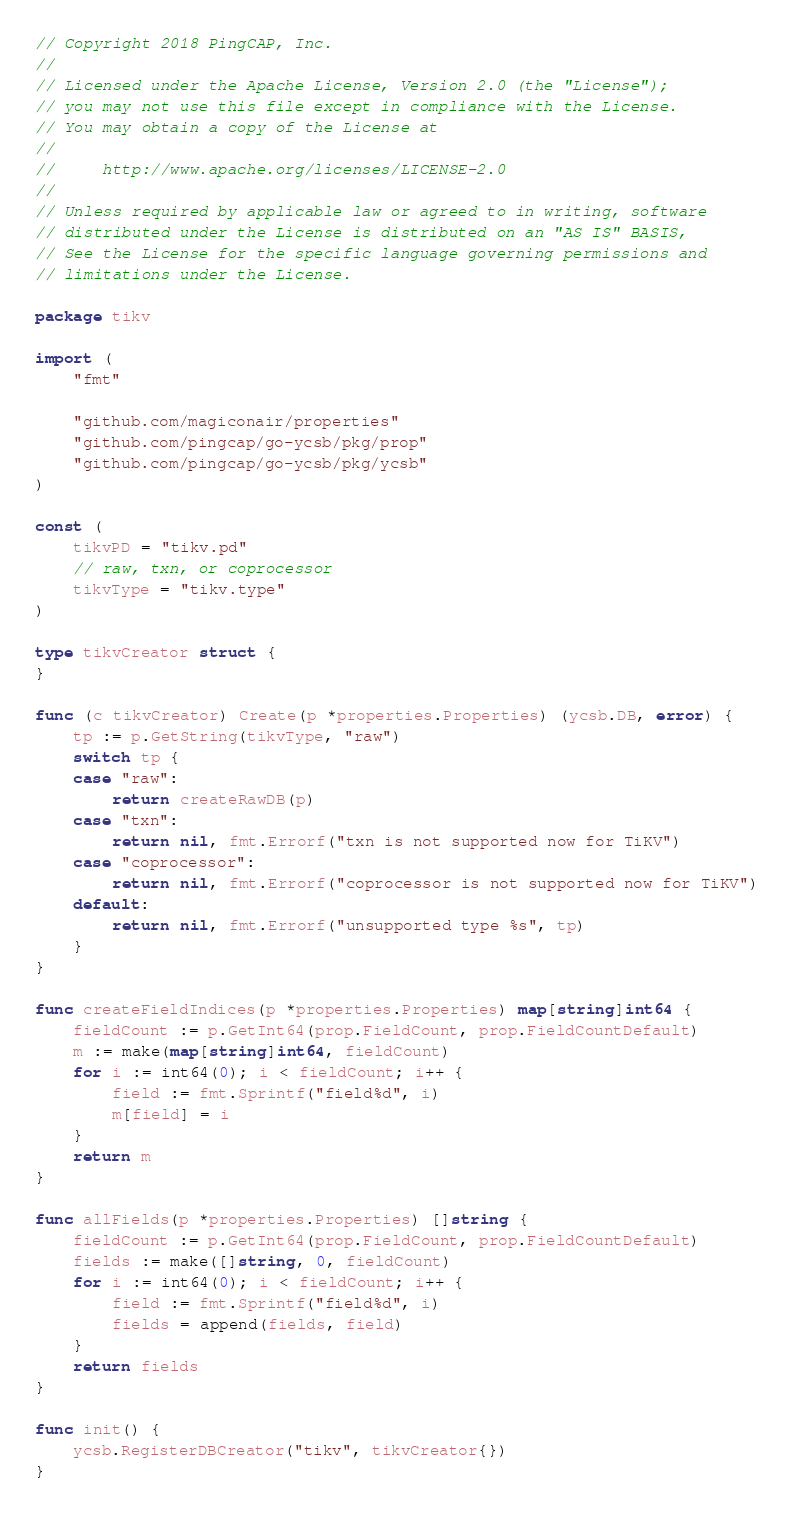<code> <loc_0><loc_0><loc_500><loc_500><_Go_>// Copyright 2018 PingCAP, Inc.
//
// Licensed under the Apache License, Version 2.0 (the "License");
// you may not use this file except in compliance with the License.
// You may obtain a copy of the License at
//
//     http://www.apache.org/licenses/LICENSE-2.0
//
// Unless required by applicable law or agreed to in writing, software
// distributed under the License is distributed on an "AS IS" BASIS,
// See the License for the specific language governing permissions and
// limitations under the License.

package tikv

import (
	"fmt"

	"github.com/magiconair/properties"
	"github.com/pingcap/go-ycsb/pkg/prop"
	"github.com/pingcap/go-ycsb/pkg/ycsb"
)

const (
	tikvPD = "tikv.pd"
	// raw, txn, or coprocessor
	tikvType = "tikv.type"
)

type tikvCreator struct {
}

func (c tikvCreator) Create(p *properties.Properties) (ycsb.DB, error) {
	tp := p.GetString(tikvType, "raw")
	switch tp {
	case "raw":
		return createRawDB(p)
	case "txn":
		return nil, fmt.Errorf("txn is not supported now for TiKV")
	case "coprocessor":
		return nil, fmt.Errorf("coprocessor is not supported now for TiKV")
	default:
		return nil, fmt.Errorf("unsupported type %s", tp)
	}
}

func createFieldIndices(p *properties.Properties) map[string]int64 {
	fieldCount := p.GetInt64(prop.FieldCount, prop.FieldCountDefault)
	m := make(map[string]int64, fieldCount)
	for i := int64(0); i < fieldCount; i++ {
		field := fmt.Sprintf("field%d", i)
		m[field] = i
	}
	return m
}

func allFields(p *properties.Properties) []string {
	fieldCount := p.GetInt64(prop.FieldCount, prop.FieldCountDefault)
	fields := make([]string, 0, fieldCount)
	for i := int64(0); i < fieldCount; i++ {
		field := fmt.Sprintf("field%d", i)
		fields = append(fields, field)
	}
	return fields
}

func init() {
	ycsb.RegisterDBCreator("tikv", tikvCreator{})
}
</code> 